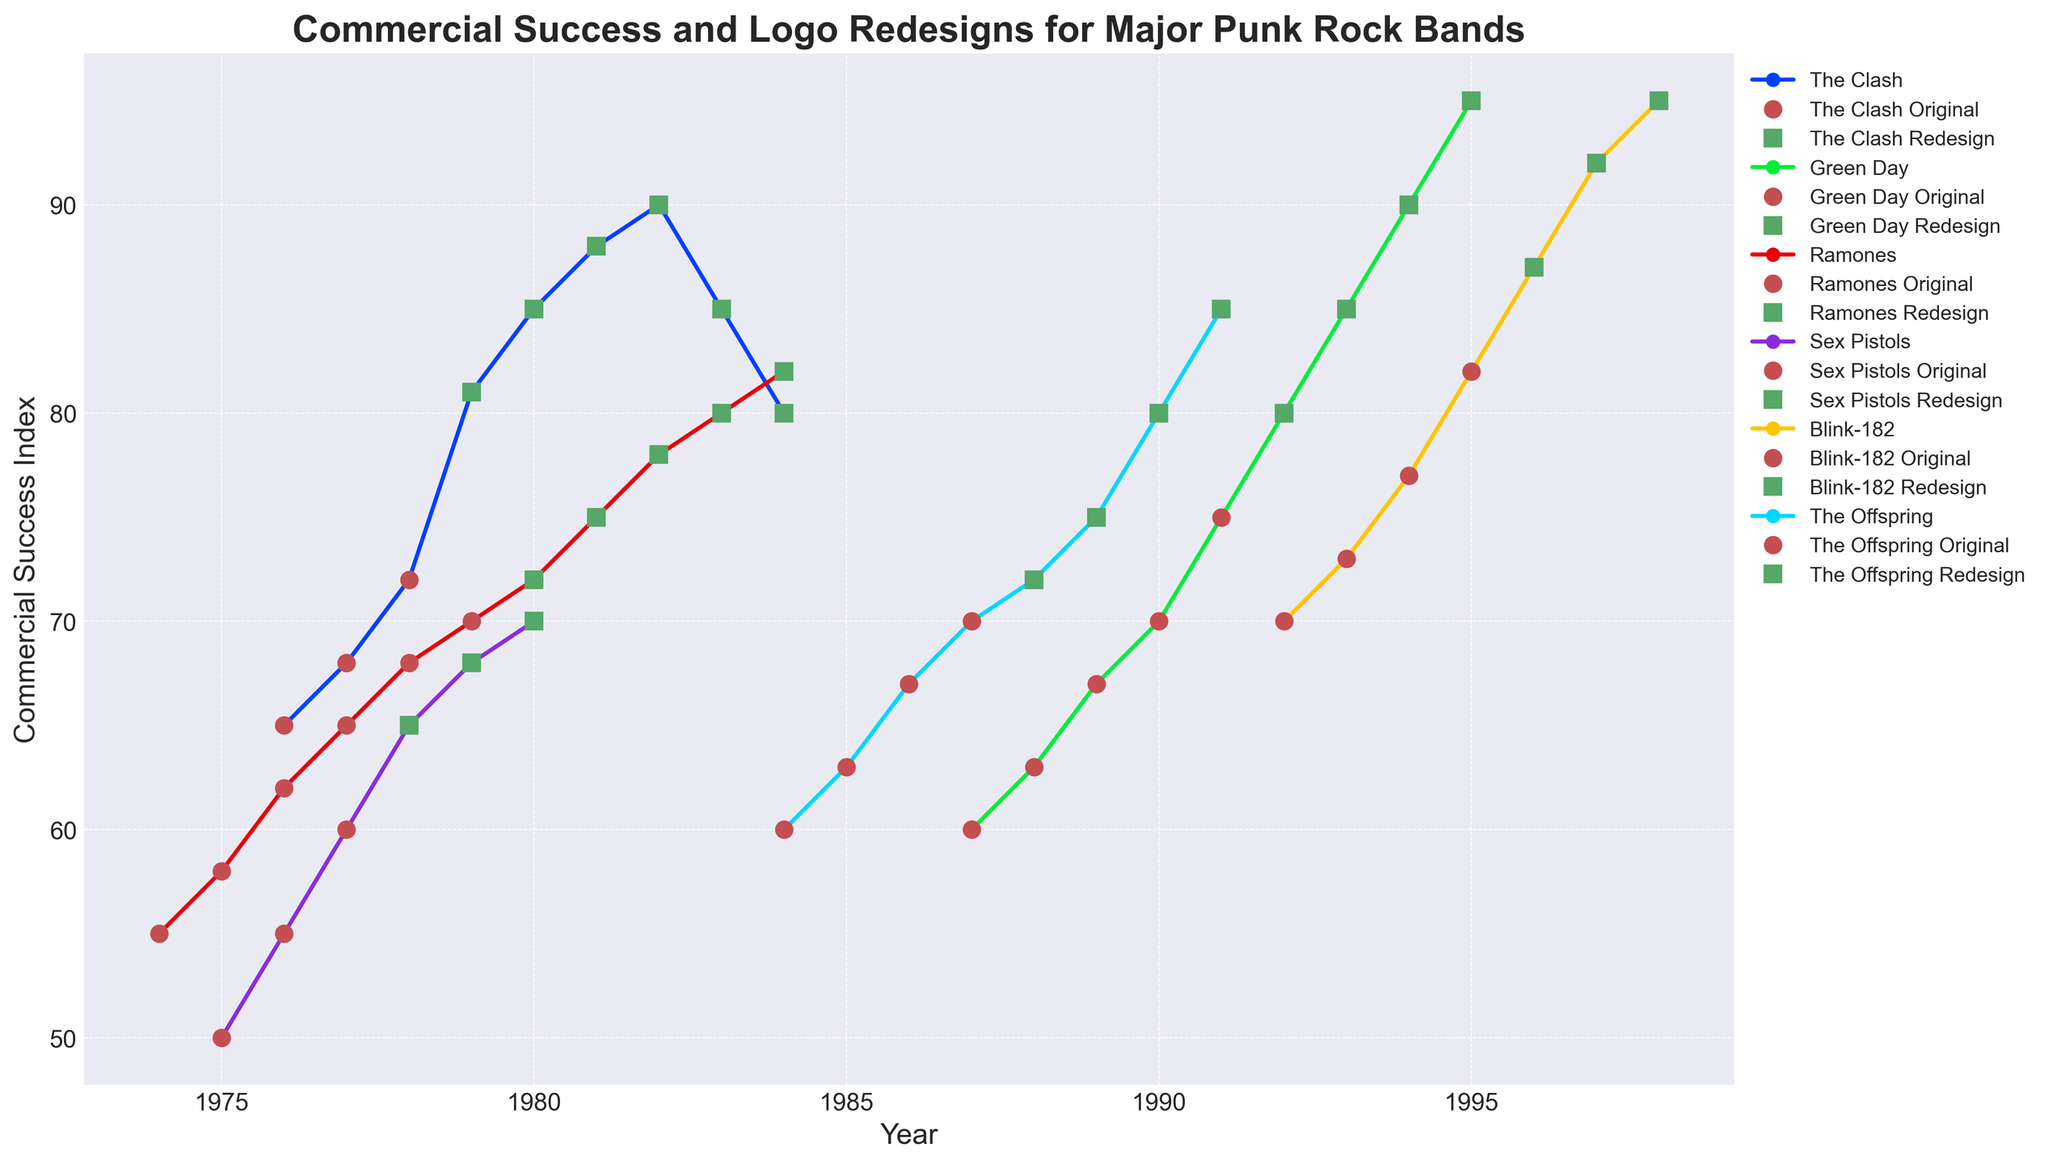How does the commercial success index of The Clash change after their logo redesign in 1979? Identify the year when The Clash redesigns their logo (1979). Then, observe the commercial success index before and after 1979. In 1979, the index is 81. After 1979, it increases to 85 in 1980, 88 in 1981, and 90 in 1982; then it starts decreasing in subsequent years.
Answer: Increases until 1982, then decreases Which band had the highest increase in commercial success index after their logo redesign? For each band, find the first year they redesign their logo and compare the commercial success index before and in subsequent years. Measure the increase. Green Day has a redesign in 1992, with an increase from 80 to 95 (15 points), which is the highest increase.
Answer: Green Day Compare the commercial success index of The Clash and The Ramones in the year of their logo redesigns. Find the years The Clash (1979) and The Ramones (1980) have redesigns. The Clash’s index in 1979 is 81, while The Ramones’ index in 1980 is 72. Compare these values.
Answer: The Clash: 81, Ramones: 72 Did any band experience a decline in commercial success after a logo redesign? Locate the redesign years for each band by looking for green squares. For each band, observe whether the commercial success index decreases in the years following the redesign. The Clash shows a decline after its peak in 1982.
Answer: Yes, The Clash Calculate the average commercial success index of Sex Pistols during the years their original logo was in use. Identify years of original logo use for Sex Pistols (1975-1977). Find the success indices for these years (50, 55, 60). Average these values: (50+55+60)/3.
Answer: 55 Identify which band's logo redesign year correlates with the highest commercial success index that year. For each band's redesign year, find the commercial success index: 
- The Clash (1979: 81)
- Green Day (1992: 80)
- Ramones (1980: 72)
- Sex Pistols (1978: 65)
- Blink-182 (1996: 87)
- The Offspring (1988: 72) The highest index is for Blink-182 in 1996 (87).
Answer: Blink-182 Compare the slopes of the commercial success indices of Green Day and The Ramones after their logo redesigns. Observe the slope or rate of change in the success index values for Green Day (starting from 1992) and The Ramones (starting from 1980). Green Day shows a consistent rise, whereas The Ramones show a more gradual increase.
Answer: Green Day's slope is steeper How many years did The Offspring use their original logo before redesigning? Identify the first and last years The Offspring used their original logo. They used it from 1984 to 1987. Subtract the start year from the end year: 1987 - 1984 = 3 years.
Answer: 3 years Which band achieved a commercial success index of 85 at some point after their logo redesign? Check each band's commercial success indices in the years following their logo redesign. Blink-182 achieves 85 in 1997.
Answer: Blink-182 